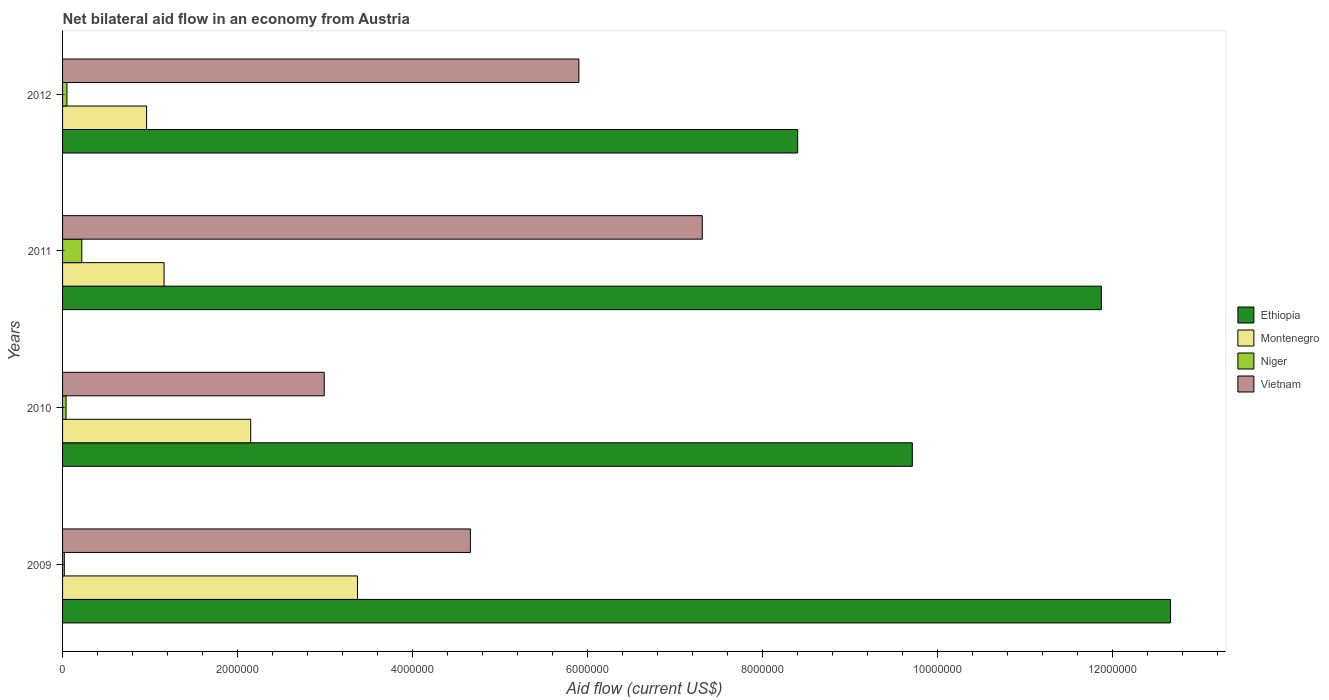How many different coloured bars are there?
Offer a terse response. 4. How many groups of bars are there?
Your response must be concise. 4. Are the number of bars per tick equal to the number of legend labels?
Your response must be concise. Yes. Are the number of bars on each tick of the Y-axis equal?
Provide a short and direct response. Yes. How many bars are there on the 1st tick from the top?
Provide a short and direct response. 4. What is the label of the 2nd group of bars from the top?
Your answer should be very brief. 2011. What is the net bilateral aid flow in Montenegro in 2009?
Give a very brief answer. 3.37e+06. Across all years, what is the maximum net bilateral aid flow in Ethiopia?
Make the answer very short. 1.27e+07. Across all years, what is the minimum net bilateral aid flow in Montenegro?
Ensure brevity in your answer.  9.60e+05. What is the total net bilateral aid flow in Ethiopia in the graph?
Offer a very short reply. 4.26e+07. What is the difference between the net bilateral aid flow in Vietnam in 2010 and the net bilateral aid flow in Ethiopia in 2011?
Ensure brevity in your answer.  -8.88e+06. What is the average net bilateral aid flow in Vietnam per year?
Keep it short and to the point. 5.22e+06. In the year 2010, what is the difference between the net bilateral aid flow in Niger and net bilateral aid flow in Vietnam?
Your answer should be very brief. -2.95e+06. In how many years, is the net bilateral aid flow in Vietnam greater than 9600000 US$?
Keep it short and to the point. 0. What is the ratio of the net bilateral aid flow in Niger in 2010 to that in 2011?
Your response must be concise. 0.18. Is the difference between the net bilateral aid flow in Niger in 2010 and 2012 greater than the difference between the net bilateral aid flow in Vietnam in 2010 and 2012?
Keep it short and to the point. Yes. What is the difference between the highest and the second highest net bilateral aid flow in Vietnam?
Keep it short and to the point. 1.41e+06. What is the difference between the highest and the lowest net bilateral aid flow in Vietnam?
Give a very brief answer. 4.32e+06. In how many years, is the net bilateral aid flow in Niger greater than the average net bilateral aid flow in Niger taken over all years?
Provide a short and direct response. 1. Is the sum of the net bilateral aid flow in Niger in 2009 and 2011 greater than the maximum net bilateral aid flow in Ethiopia across all years?
Offer a terse response. No. Is it the case that in every year, the sum of the net bilateral aid flow in Niger and net bilateral aid flow in Montenegro is greater than the sum of net bilateral aid flow in Ethiopia and net bilateral aid flow in Vietnam?
Give a very brief answer. No. What does the 4th bar from the top in 2009 represents?
Keep it short and to the point. Ethiopia. What does the 1st bar from the bottom in 2011 represents?
Offer a very short reply. Ethiopia. Is it the case that in every year, the sum of the net bilateral aid flow in Ethiopia and net bilateral aid flow in Vietnam is greater than the net bilateral aid flow in Niger?
Offer a very short reply. Yes. How many bars are there?
Provide a succinct answer. 16. Are all the bars in the graph horizontal?
Offer a very short reply. Yes. How many years are there in the graph?
Keep it short and to the point. 4. Are the values on the major ticks of X-axis written in scientific E-notation?
Make the answer very short. No. Does the graph contain any zero values?
Provide a succinct answer. No. How are the legend labels stacked?
Offer a terse response. Vertical. What is the title of the graph?
Ensure brevity in your answer.  Net bilateral aid flow in an economy from Austria. What is the label or title of the Y-axis?
Your response must be concise. Years. What is the Aid flow (current US$) in Ethiopia in 2009?
Your answer should be compact. 1.27e+07. What is the Aid flow (current US$) in Montenegro in 2009?
Make the answer very short. 3.37e+06. What is the Aid flow (current US$) of Vietnam in 2009?
Your response must be concise. 4.66e+06. What is the Aid flow (current US$) of Ethiopia in 2010?
Your answer should be very brief. 9.71e+06. What is the Aid flow (current US$) in Montenegro in 2010?
Make the answer very short. 2.15e+06. What is the Aid flow (current US$) in Vietnam in 2010?
Offer a very short reply. 2.99e+06. What is the Aid flow (current US$) in Ethiopia in 2011?
Your answer should be compact. 1.19e+07. What is the Aid flow (current US$) in Montenegro in 2011?
Ensure brevity in your answer.  1.16e+06. What is the Aid flow (current US$) of Niger in 2011?
Offer a very short reply. 2.20e+05. What is the Aid flow (current US$) in Vietnam in 2011?
Ensure brevity in your answer.  7.31e+06. What is the Aid flow (current US$) in Ethiopia in 2012?
Keep it short and to the point. 8.40e+06. What is the Aid flow (current US$) in Montenegro in 2012?
Your response must be concise. 9.60e+05. What is the Aid flow (current US$) of Niger in 2012?
Your response must be concise. 5.00e+04. What is the Aid flow (current US$) in Vietnam in 2012?
Offer a terse response. 5.90e+06. Across all years, what is the maximum Aid flow (current US$) in Ethiopia?
Keep it short and to the point. 1.27e+07. Across all years, what is the maximum Aid flow (current US$) of Montenegro?
Give a very brief answer. 3.37e+06. Across all years, what is the maximum Aid flow (current US$) of Niger?
Provide a short and direct response. 2.20e+05. Across all years, what is the maximum Aid flow (current US$) of Vietnam?
Your answer should be compact. 7.31e+06. Across all years, what is the minimum Aid flow (current US$) in Ethiopia?
Give a very brief answer. 8.40e+06. Across all years, what is the minimum Aid flow (current US$) in Montenegro?
Offer a very short reply. 9.60e+05. Across all years, what is the minimum Aid flow (current US$) in Niger?
Offer a terse response. 2.00e+04. Across all years, what is the minimum Aid flow (current US$) of Vietnam?
Provide a short and direct response. 2.99e+06. What is the total Aid flow (current US$) in Ethiopia in the graph?
Your answer should be very brief. 4.26e+07. What is the total Aid flow (current US$) in Montenegro in the graph?
Make the answer very short. 7.64e+06. What is the total Aid flow (current US$) of Vietnam in the graph?
Provide a short and direct response. 2.09e+07. What is the difference between the Aid flow (current US$) in Ethiopia in 2009 and that in 2010?
Keep it short and to the point. 2.95e+06. What is the difference between the Aid flow (current US$) in Montenegro in 2009 and that in 2010?
Your response must be concise. 1.22e+06. What is the difference between the Aid flow (current US$) of Vietnam in 2009 and that in 2010?
Offer a terse response. 1.67e+06. What is the difference between the Aid flow (current US$) of Ethiopia in 2009 and that in 2011?
Keep it short and to the point. 7.90e+05. What is the difference between the Aid flow (current US$) in Montenegro in 2009 and that in 2011?
Provide a succinct answer. 2.21e+06. What is the difference between the Aid flow (current US$) in Vietnam in 2009 and that in 2011?
Offer a very short reply. -2.65e+06. What is the difference between the Aid flow (current US$) in Ethiopia in 2009 and that in 2012?
Provide a succinct answer. 4.26e+06. What is the difference between the Aid flow (current US$) in Montenegro in 2009 and that in 2012?
Your answer should be very brief. 2.41e+06. What is the difference between the Aid flow (current US$) in Vietnam in 2009 and that in 2012?
Give a very brief answer. -1.24e+06. What is the difference between the Aid flow (current US$) of Ethiopia in 2010 and that in 2011?
Offer a very short reply. -2.16e+06. What is the difference between the Aid flow (current US$) of Montenegro in 2010 and that in 2011?
Keep it short and to the point. 9.90e+05. What is the difference between the Aid flow (current US$) in Vietnam in 2010 and that in 2011?
Offer a very short reply. -4.32e+06. What is the difference between the Aid flow (current US$) in Ethiopia in 2010 and that in 2012?
Your answer should be compact. 1.31e+06. What is the difference between the Aid flow (current US$) in Montenegro in 2010 and that in 2012?
Your answer should be very brief. 1.19e+06. What is the difference between the Aid flow (current US$) in Niger in 2010 and that in 2012?
Provide a succinct answer. -10000. What is the difference between the Aid flow (current US$) in Vietnam in 2010 and that in 2012?
Your response must be concise. -2.91e+06. What is the difference between the Aid flow (current US$) in Ethiopia in 2011 and that in 2012?
Ensure brevity in your answer.  3.47e+06. What is the difference between the Aid flow (current US$) of Montenegro in 2011 and that in 2012?
Make the answer very short. 2.00e+05. What is the difference between the Aid flow (current US$) in Niger in 2011 and that in 2012?
Make the answer very short. 1.70e+05. What is the difference between the Aid flow (current US$) in Vietnam in 2011 and that in 2012?
Your answer should be very brief. 1.41e+06. What is the difference between the Aid flow (current US$) of Ethiopia in 2009 and the Aid flow (current US$) of Montenegro in 2010?
Ensure brevity in your answer.  1.05e+07. What is the difference between the Aid flow (current US$) of Ethiopia in 2009 and the Aid flow (current US$) of Niger in 2010?
Your response must be concise. 1.26e+07. What is the difference between the Aid flow (current US$) in Ethiopia in 2009 and the Aid flow (current US$) in Vietnam in 2010?
Offer a terse response. 9.67e+06. What is the difference between the Aid flow (current US$) of Montenegro in 2009 and the Aid flow (current US$) of Niger in 2010?
Provide a short and direct response. 3.33e+06. What is the difference between the Aid flow (current US$) in Niger in 2009 and the Aid flow (current US$) in Vietnam in 2010?
Keep it short and to the point. -2.97e+06. What is the difference between the Aid flow (current US$) of Ethiopia in 2009 and the Aid flow (current US$) of Montenegro in 2011?
Provide a succinct answer. 1.15e+07. What is the difference between the Aid flow (current US$) of Ethiopia in 2009 and the Aid flow (current US$) of Niger in 2011?
Your answer should be very brief. 1.24e+07. What is the difference between the Aid flow (current US$) of Ethiopia in 2009 and the Aid flow (current US$) of Vietnam in 2011?
Provide a succinct answer. 5.35e+06. What is the difference between the Aid flow (current US$) in Montenegro in 2009 and the Aid flow (current US$) in Niger in 2011?
Your response must be concise. 3.15e+06. What is the difference between the Aid flow (current US$) of Montenegro in 2009 and the Aid flow (current US$) of Vietnam in 2011?
Ensure brevity in your answer.  -3.94e+06. What is the difference between the Aid flow (current US$) of Niger in 2009 and the Aid flow (current US$) of Vietnam in 2011?
Make the answer very short. -7.29e+06. What is the difference between the Aid flow (current US$) in Ethiopia in 2009 and the Aid flow (current US$) in Montenegro in 2012?
Your answer should be compact. 1.17e+07. What is the difference between the Aid flow (current US$) in Ethiopia in 2009 and the Aid flow (current US$) in Niger in 2012?
Make the answer very short. 1.26e+07. What is the difference between the Aid flow (current US$) of Ethiopia in 2009 and the Aid flow (current US$) of Vietnam in 2012?
Ensure brevity in your answer.  6.76e+06. What is the difference between the Aid flow (current US$) in Montenegro in 2009 and the Aid flow (current US$) in Niger in 2012?
Provide a succinct answer. 3.32e+06. What is the difference between the Aid flow (current US$) of Montenegro in 2009 and the Aid flow (current US$) of Vietnam in 2012?
Your response must be concise. -2.53e+06. What is the difference between the Aid flow (current US$) in Niger in 2009 and the Aid flow (current US$) in Vietnam in 2012?
Your answer should be very brief. -5.88e+06. What is the difference between the Aid flow (current US$) in Ethiopia in 2010 and the Aid flow (current US$) in Montenegro in 2011?
Your answer should be compact. 8.55e+06. What is the difference between the Aid flow (current US$) of Ethiopia in 2010 and the Aid flow (current US$) of Niger in 2011?
Your response must be concise. 9.49e+06. What is the difference between the Aid flow (current US$) of Ethiopia in 2010 and the Aid flow (current US$) of Vietnam in 2011?
Your response must be concise. 2.40e+06. What is the difference between the Aid flow (current US$) of Montenegro in 2010 and the Aid flow (current US$) of Niger in 2011?
Offer a very short reply. 1.93e+06. What is the difference between the Aid flow (current US$) in Montenegro in 2010 and the Aid flow (current US$) in Vietnam in 2011?
Offer a very short reply. -5.16e+06. What is the difference between the Aid flow (current US$) in Niger in 2010 and the Aid flow (current US$) in Vietnam in 2011?
Make the answer very short. -7.27e+06. What is the difference between the Aid flow (current US$) in Ethiopia in 2010 and the Aid flow (current US$) in Montenegro in 2012?
Your answer should be compact. 8.75e+06. What is the difference between the Aid flow (current US$) in Ethiopia in 2010 and the Aid flow (current US$) in Niger in 2012?
Ensure brevity in your answer.  9.66e+06. What is the difference between the Aid flow (current US$) in Ethiopia in 2010 and the Aid flow (current US$) in Vietnam in 2012?
Your answer should be compact. 3.81e+06. What is the difference between the Aid flow (current US$) of Montenegro in 2010 and the Aid flow (current US$) of Niger in 2012?
Your answer should be very brief. 2.10e+06. What is the difference between the Aid flow (current US$) in Montenegro in 2010 and the Aid flow (current US$) in Vietnam in 2012?
Provide a succinct answer. -3.75e+06. What is the difference between the Aid flow (current US$) in Niger in 2010 and the Aid flow (current US$) in Vietnam in 2012?
Ensure brevity in your answer.  -5.86e+06. What is the difference between the Aid flow (current US$) of Ethiopia in 2011 and the Aid flow (current US$) of Montenegro in 2012?
Ensure brevity in your answer.  1.09e+07. What is the difference between the Aid flow (current US$) of Ethiopia in 2011 and the Aid flow (current US$) of Niger in 2012?
Ensure brevity in your answer.  1.18e+07. What is the difference between the Aid flow (current US$) in Ethiopia in 2011 and the Aid flow (current US$) in Vietnam in 2012?
Provide a succinct answer. 5.97e+06. What is the difference between the Aid flow (current US$) of Montenegro in 2011 and the Aid flow (current US$) of Niger in 2012?
Your answer should be very brief. 1.11e+06. What is the difference between the Aid flow (current US$) of Montenegro in 2011 and the Aid flow (current US$) of Vietnam in 2012?
Provide a short and direct response. -4.74e+06. What is the difference between the Aid flow (current US$) in Niger in 2011 and the Aid flow (current US$) in Vietnam in 2012?
Provide a succinct answer. -5.68e+06. What is the average Aid flow (current US$) in Ethiopia per year?
Provide a succinct answer. 1.07e+07. What is the average Aid flow (current US$) of Montenegro per year?
Your response must be concise. 1.91e+06. What is the average Aid flow (current US$) of Niger per year?
Keep it short and to the point. 8.25e+04. What is the average Aid flow (current US$) of Vietnam per year?
Your answer should be very brief. 5.22e+06. In the year 2009, what is the difference between the Aid flow (current US$) in Ethiopia and Aid flow (current US$) in Montenegro?
Offer a terse response. 9.29e+06. In the year 2009, what is the difference between the Aid flow (current US$) of Ethiopia and Aid flow (current US$) of Niger?
Your answer should be very brief. 1.26e+07. In the year 2009, what is the difference between the Aid flow (current US$) of Ethiopia and Aid flow (current US$) of Vietnam?
Keep it short and to the point. 8.00e+06. In the year 2009, what is the difference between the Aid flow (current US$) in Montenegro and Aid flow (current US$) in Niger?
Your response must be concise. 3.35e+06. In the year 2009, what is the difference between the Aid flow (current US$) of Montenegro and Aid flow (current US$) of Vietnam?
Provide a succinct answer. -1.29e+06. In the year 2009, what is the difference between the Aid flow (current US$) of Niger and Aid flow (current US$) of Vietnam?
Your response must be concise. -4.64e+06. In the year 2010, what is the difference between the Aid flow (current US$) in Ethiopia and Aid flow (current US$) in Montenegro?
Give a very brief answer. 7.56e+06. In the year 2010, what is the difference between the Aid flow (current US$) of Ethiopia and Aid flow (current US$) of Niger?
Offer a very short reply. 9.67e+06. In the year 2010, what is the difference between the Aid flow (current US$) in Ethiopia and Aid flow (current US$) in Vietnam?
Offer a very short reply. 6.72e+06. In the year 2010, what is the difference between the Aid flow (current US$) in Montenegro and Aid flow (current US$) in Niger?
Offer a very short reply. 2.11e+06. In the year 2010, what is the difference between the Aid flow (current US$) in Montenegro and Aid flow (current US$) in Vietnam?
Provide a short and direct response. -8.40e+05. In the year 2010, what is the difference between the Aid flow (current US$) of Niger and Aid flow (current US$) of Vietnam?
Your answer should be compact. -2.95e+06. In the year 2011, what is the difference between the Aid flow (current US$) in Ethiopia and Aid flow (current US$) in Montenegro?
Your answer should be compact. 1.07e+07. In the year 2011, what is the difference between the Aid flow (current US$) in Ethiopia and Aid flow (current US$) in Niger?
Your response must be concise. 1.16e+07. In the year 2011, what is the difference between the Aid flow (current US$) in Ethiopia and Aid flow (current US$) in Vietnam?
Give a very brief answer. 4.56e+06. In the year 2011, what is the difference between the Aid flow (current US$) in Montenegro and Aid flow (current US$) in Niger?
Offer a terse response. 9.40e+05. In the year 2011, what is the difference between the Aid flow (current US$) of Montenegro and Aid flow (current US$) of Vietnam?
Your answer should be very brief. -6.15e+06. In the year 2011, what is the difference between the Aid flow (current US$) in Niger and Aid flow (current US$) in Vietnam?
Offer a very short reply. -7.09e+06. In the year 2012, what is the difference between the Aid flow (current US$) of Ethiopia and Aid flow (current US$) of Montenegro?
Your response must be concise. 7.44e+06. In the year 2012, what is the difference between the Aid flow (current US$) in Ethiopia and Aid flow (current US$) in Niger?
Offer a very short reply. 8.35e+06. In the year 2012, what is the difference between the Aid flow (current US$) of Ethiopia and Aid flow (current US$) of Vietnam?
Provide a short and direct response. 2.50e+06. In the year 2012, what is the difference between the Aid flow (current US$) in Montenegro and Aid flow (current US$) in Niger?
Your answer should be compact. 9.10e+05. In the year 2012, what is the difference between the Aid flow (current US$) in Montenegro and Aid flow (current US$) in Vietnam?
Provide a succinct answer. -4.94e+06. In the year 2012, what is the difference between the Aid flow (current US$) in Niger and Aid flow (current US$) in Vietnam?
Your response must be concise. -5.85e+06. What is the ratio of the Aid flow (current US$) in Ethiopia in 2009 to that in 2010?
Ensure brevity in your answer.  1.3. What is the ratio of the Aid flow (current US$) in Montenegro in 2009 to that in 2010?
Keep it short and to the point. 1.57. What is the ratio of the Aid flow (current US$) in Vietnam in 2009 to that in 2010?
Your answer should be very brief. 1.56. What is the ratio of the Aid flow (current US$) in Ethiopia in 2009 to that in 2011?
Ensure brevity in your answer.  1.07. What is the ratio of the Aid flow (current US$) of Montenegro in 2009 to that in 2011?
Provide a short and direct response. 2.91. What is the ratio of the Aid flow (current US$) of Niger in 2009 to that in 2011?
Your response must be concise. 0.09. What is the ratio of the Aid flow (current US$) in Vietnam in 2009 to that in 2011?
Give a very brief answer. 0.64. What is the ratio of the Aid flow (current US$) in Ethiopia in 2009 to that in 2012?
Your response must be concise. 1.51. What is the ratio of the Aid flow (current US$) in Montenegro in 2009 to that in 2012?
Provide a succinct answer. 3.51. What is the ratio of the Aid flow (current US$) of Niger in 2009 to that in 2012?
Make the answer very short. 0.4. What is the ratio of the Aid flow (current US$) of Vietnam in 2009 to that in 2012?
Give a very brief answer. 0.79. What is the ratio of the Aid flow (current US$) of Ethiopia in 2010 to that in 2011?
Provide a short and direct response. 0.82. What is the ratio of the Aid flow (current US$) of Montenegro in 2010 to that in 2011?
Offer a very short reply. 1.85. What is the ratio of the Aid flow (current US$) of Niger in 2010 to that in 2011?
Provide a succinct answer. 0.18. What is the ratio of the Aid flow (current US$) in Vietnam in 2010 to that in 2011?
Give a very brief answer. 0.41. What is the ratio of the Aid flow (current US$) in Ethiopia in 2010 to that in 2012?
Your response must be concise. 1.16. What is the ratio of the Aid flow (current US$) of Montenegro in 2010 to that in 2012?
Your answer should be very brief. 2.24. What is the ratio of the Aid flow (current US$) of Vietnam in 2010 to that in 2012?
Offer a terse response. 0.51. What is the ratio of the Aid flow (current US$) in Ethiopia in 2011 to that in 2012?
Keep it short and to the point. 1.41. What is the ratio of the Aid flow (current US$) of Montenegro in 2011 to that in 2012?
Make the answer very short. 1.21. What is the ratio of the Aid flow (current US$) of Vietnam in 2011 to that in 2012?
Make the answer very short. 1.24. What is the difference between the highest and the second highest Aid flow (current US$) of Ethiopia?
Your answer should be very brief. 7.90e+05. What is the difference between the highest and the second highest Aid flow (current US$) in Montenegro?
Make the answer very short. 1.22e+06. What is the difference between the highest and the second highest Aid flow (current US$) of Vietnam?
Keep it short and to the point. 1.41e+06. What is the difference between the highest and the lowest Aid flow (current US$) of Ethiopia?
Provide a short and direct response. 4.26e+06. What is the difference between the highest and the lowest Aid flow (current US$) of Montenegro?
Your answer should be compact. 2.41e+06. What is the difference between the highest and the lowest Aid flow (current US$) in Vietnam?
Offer a very short reply. 4.32e+06. 